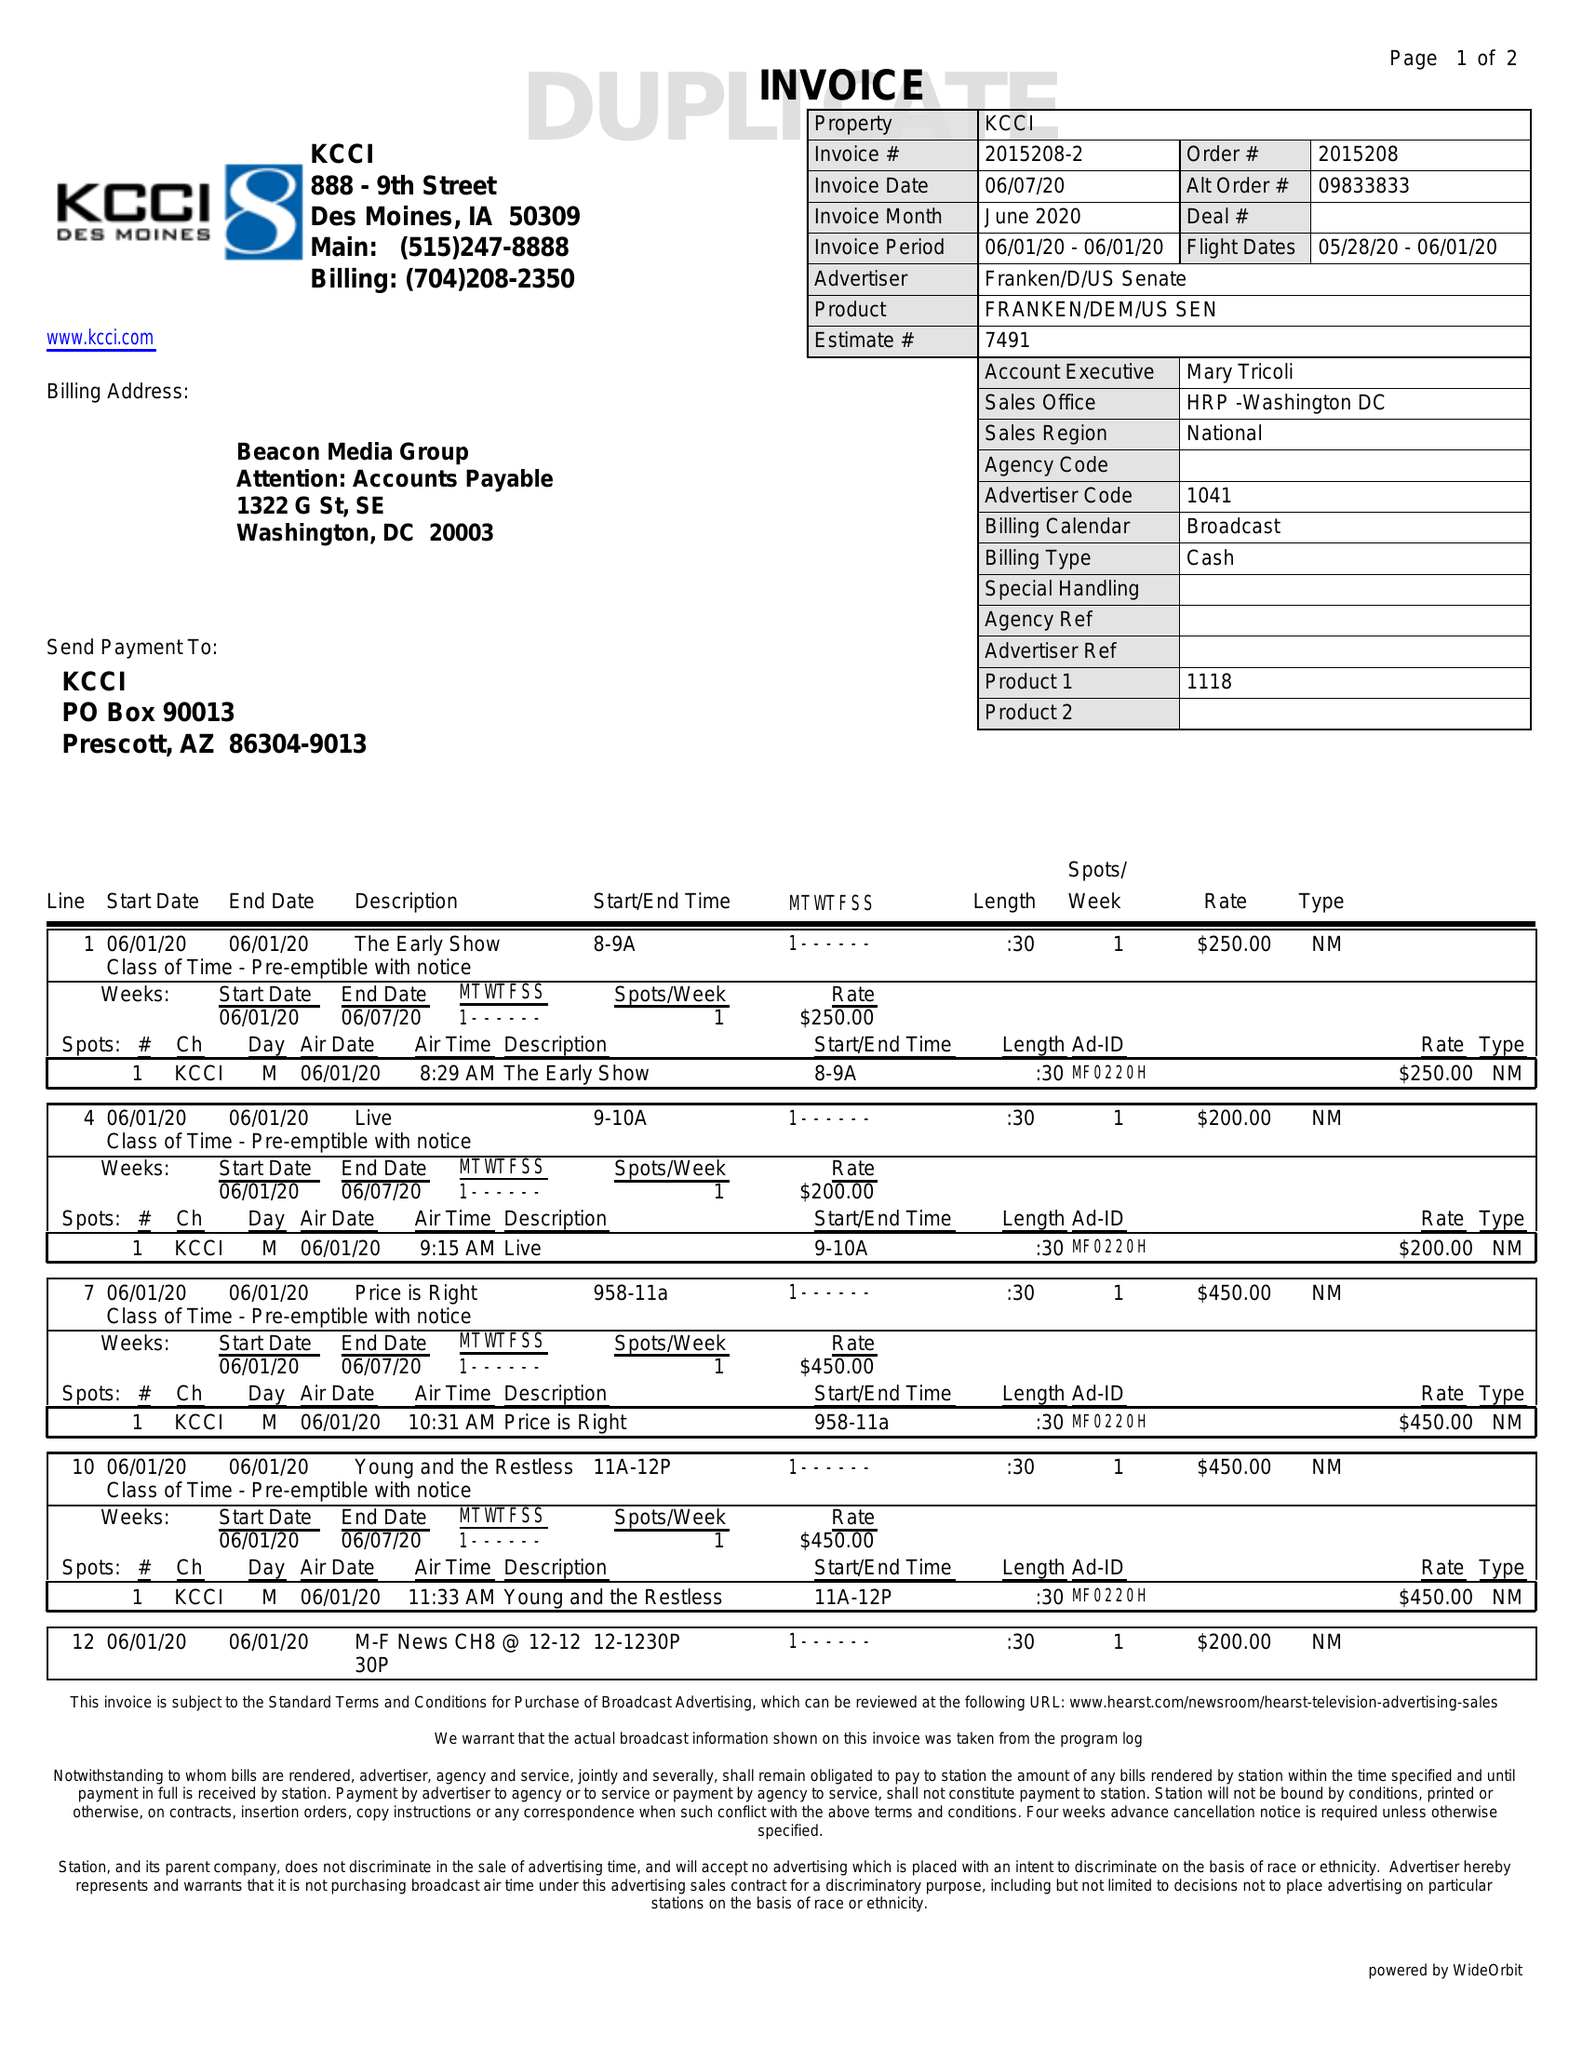What is the value for the advertiser?
Answer the question using a single word or phrase. FRANKEN/D/USSENATE 